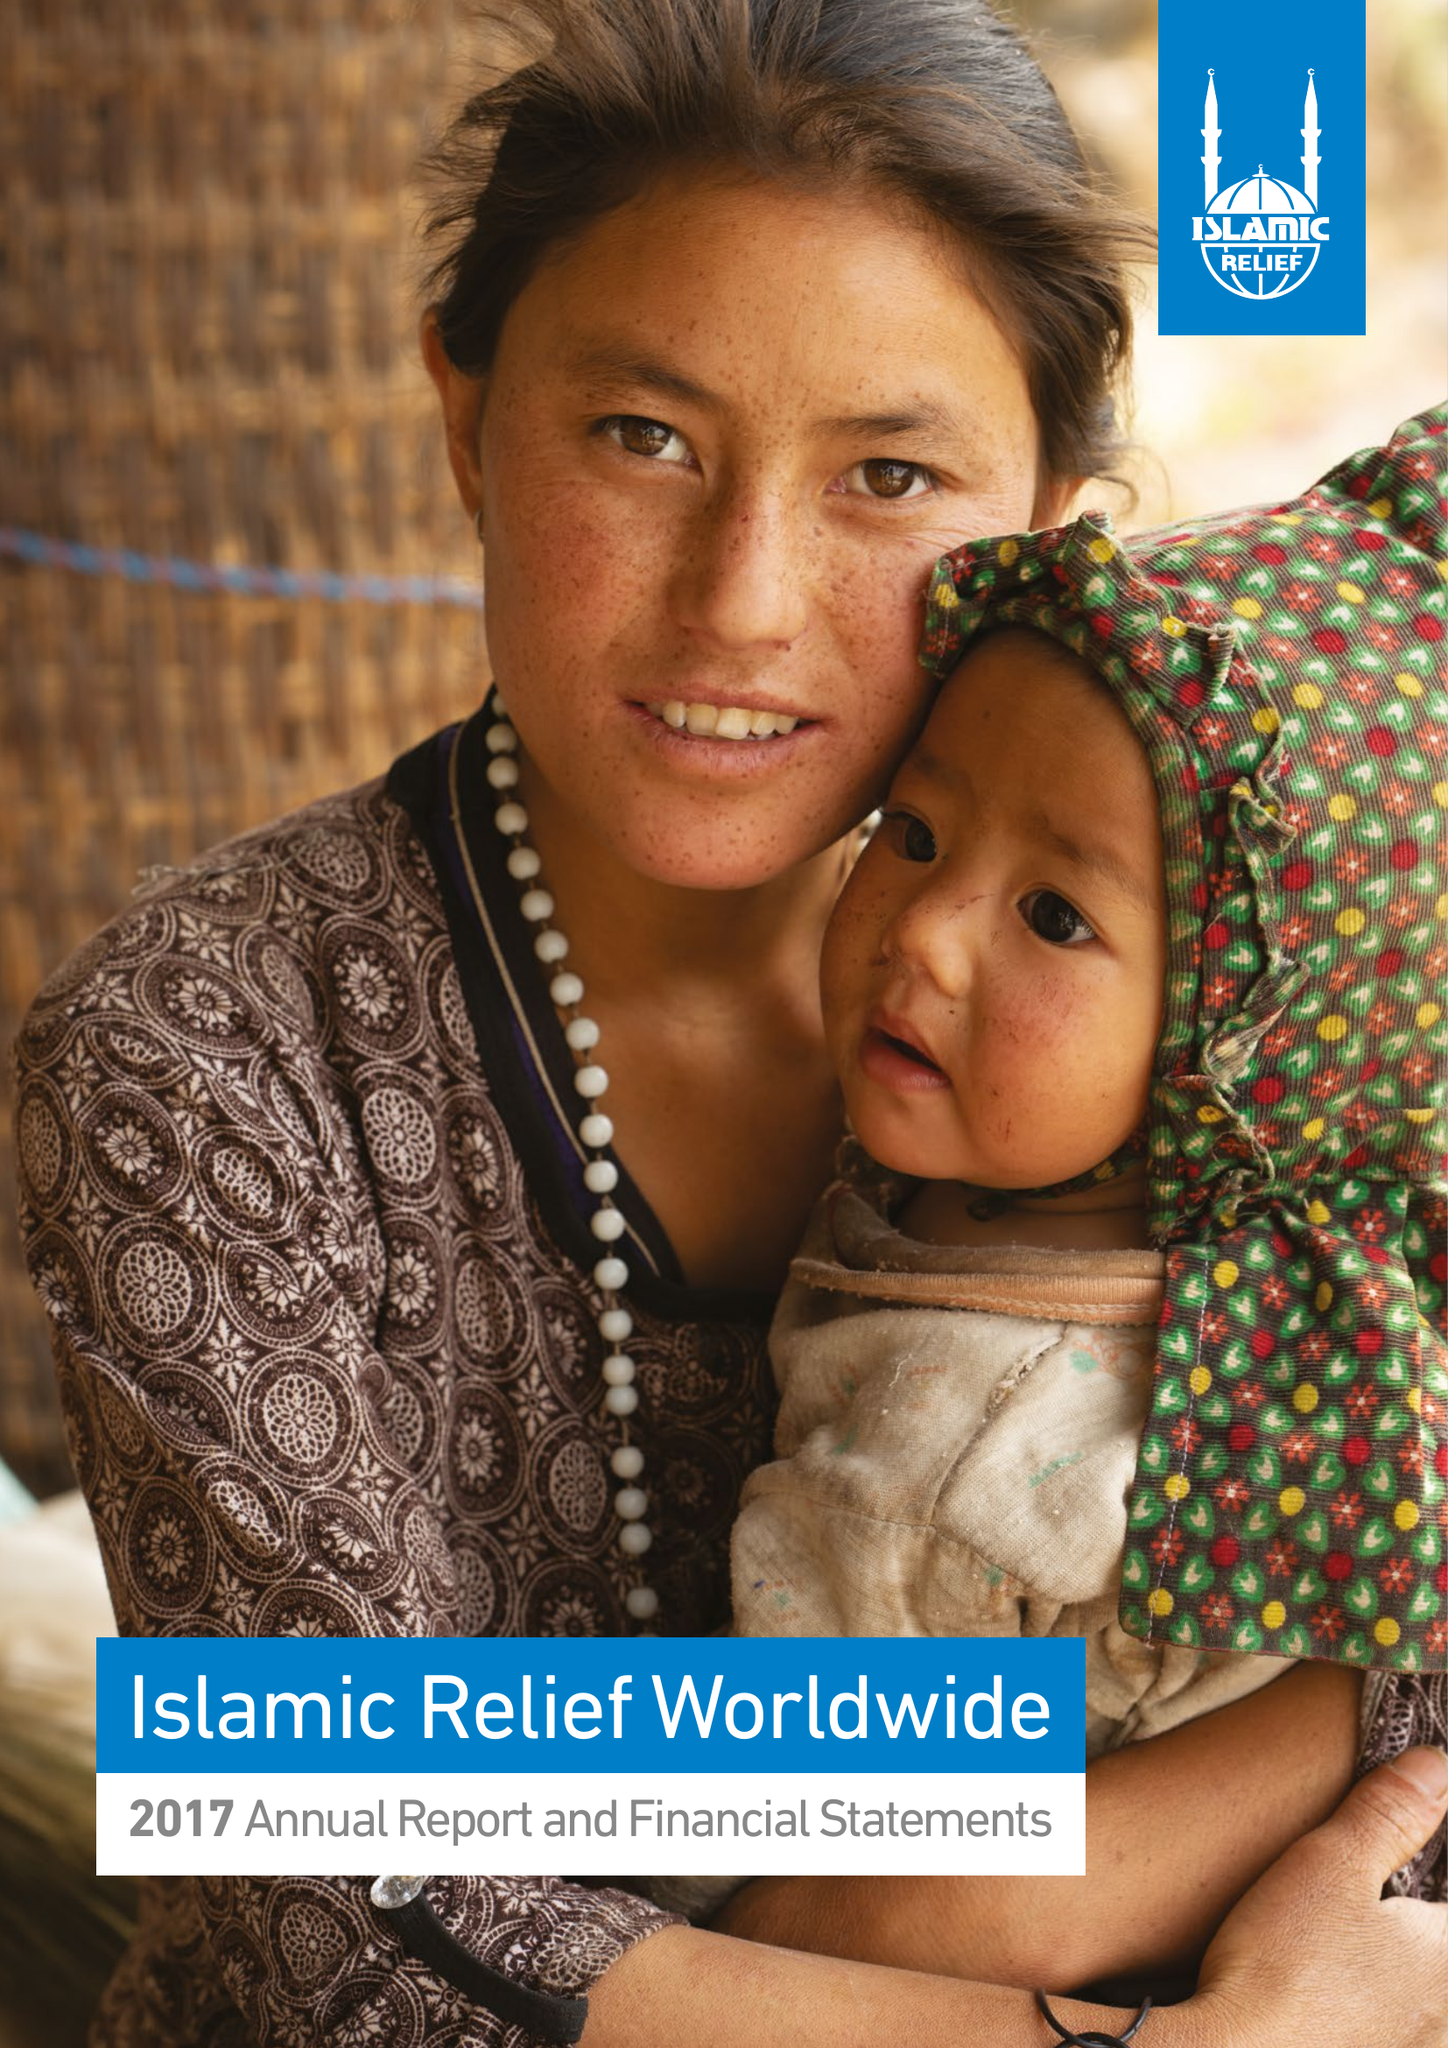What is the value for the spending_annually_in_british_pounds?
Answer the question using a single word or phrase. 124728803.00 